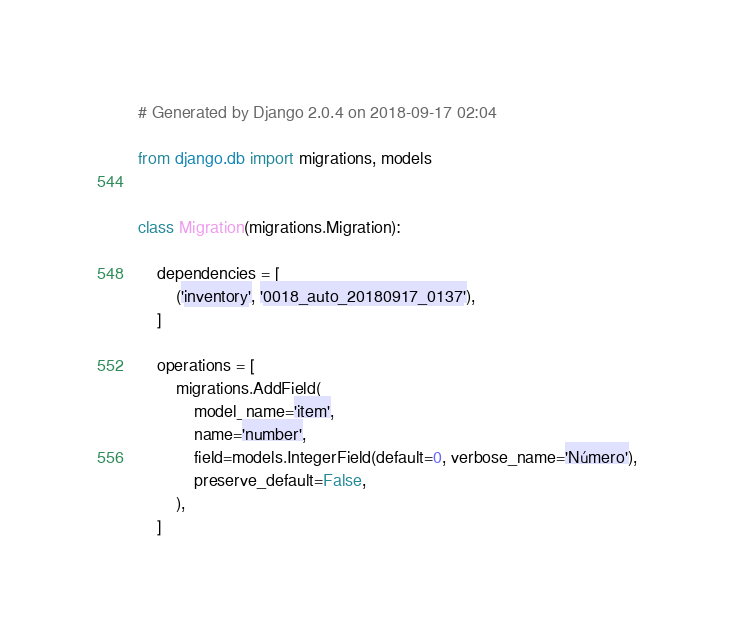Convert code to text. <code><loc_0><loc_0><loc_500><loc_500><_Python_># Generated by Django 2.0.4 on 2018-09-17 02:04

from django.db import migrations, models


class Migration(migrations.Migration):

    dependencies = [
        ('inventory', '0018_auto_20180917_0137'),
    ]

    operations = [
        migrations.AddField(
            model_name='item',
            name='number',
            field=models.IntegerField(default=0, verbose_name='Número'),
            preserve_default=False,
        ),
    ]
</code> 